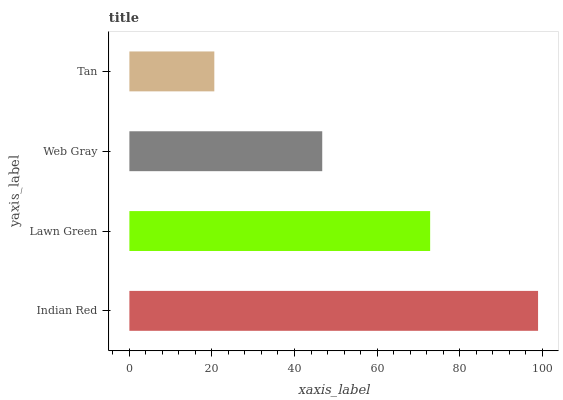Is Tan the minimum?
Answer yes or no. Yes. Is Indian Red the maximum?
Answer yes or no. Yes. Is Lawn Green the minimum?
Answer yes or no. No. Is Lawn Green the maximum?
Answer yes or no. No. Is Indian Red greater than Lawn Green?
Answer yes or no. Yes. Is Lawn Green less than Indian Red?
Answer yes or no. Yes. Is Lawn Green greater than Indian Red?
Answer yes or no. No. Is Indian Red less than Lawn Green?
Answer yes or no. No. Is Lawn Green the high median?
Answer yes or no. Yes. Is Web Gray the low median?
Answer yes or no. Yes. Is Web Gray the high median?
Answer yes or no. No. Is Tan the low median?
Answer yes or no. No. 